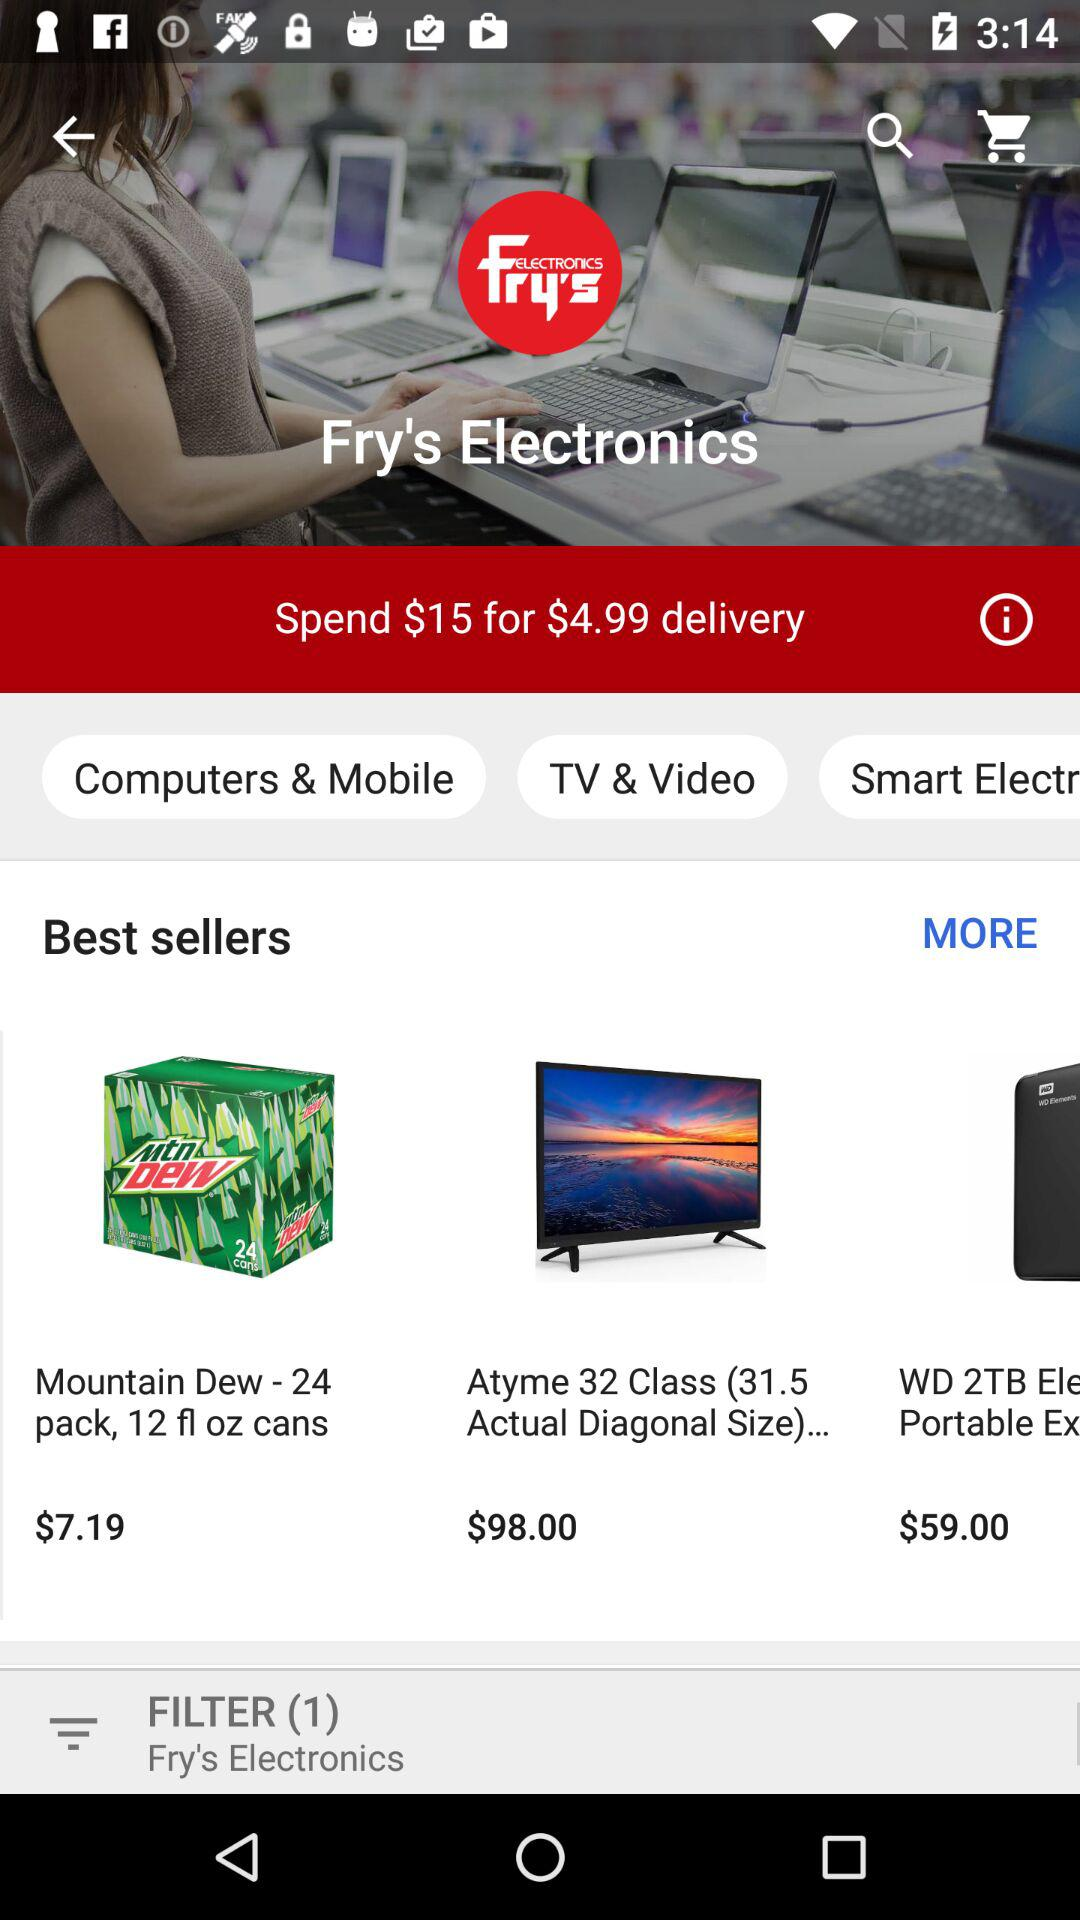What is the application name? The application name is "Fry's Electronics". 